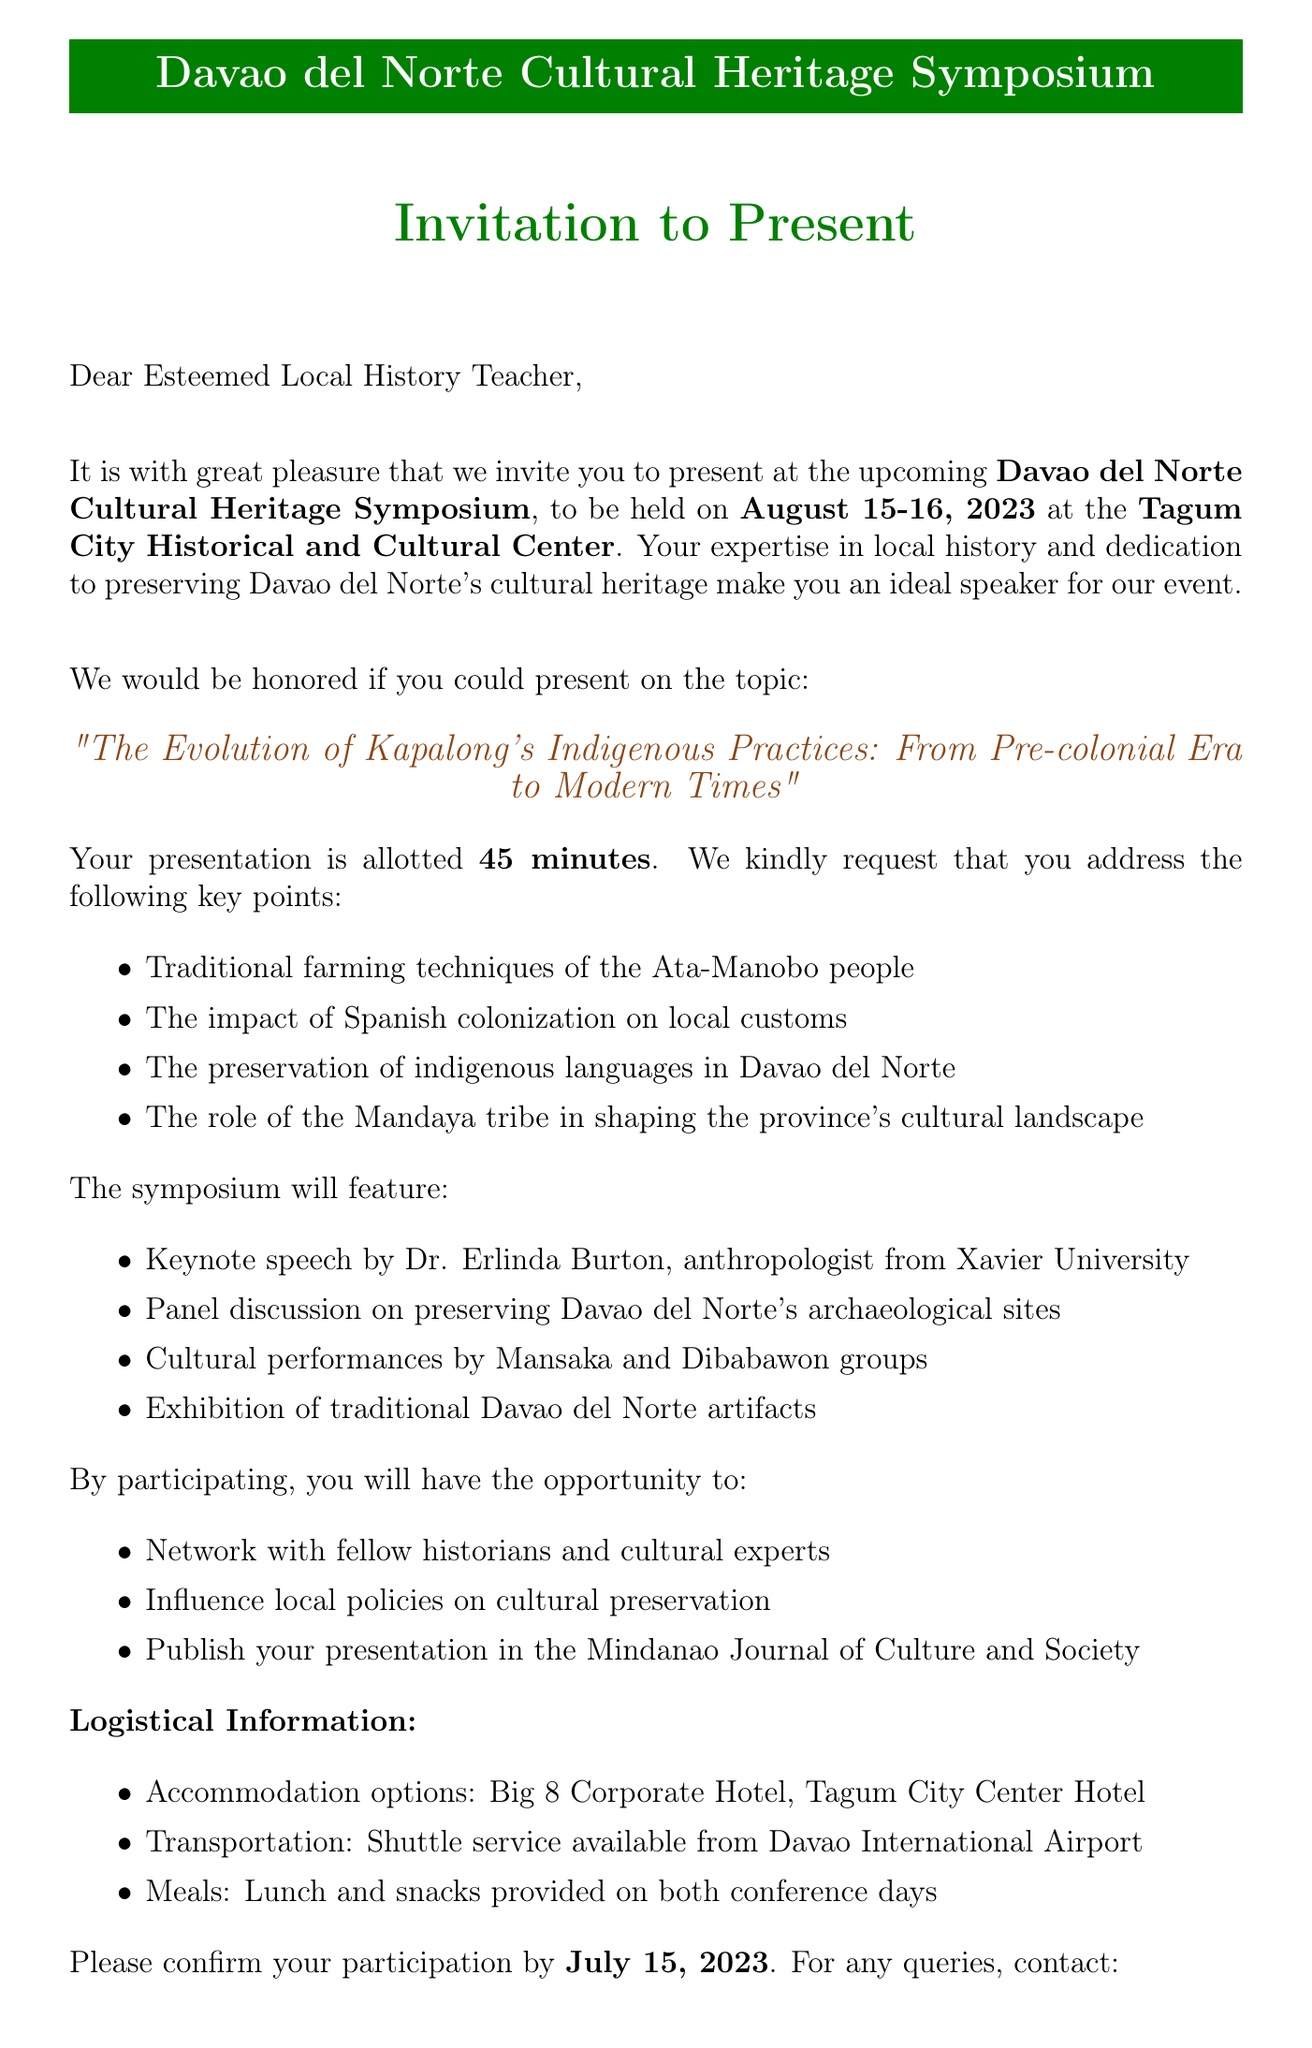What is the name of the conference? The name of the conference is specified in the document, which is the Davao del Norte Cultural Heritage Symposium.
Answer: Davao del Norte Cultural Heritage Symposium When will the symposium take place? The document states the date of the symposium as August 15-16, 2023.
Answer: August 15-16, 2023 Who is the organizer of the symposium? The document mentions that the organizer of the event is the Davao del Norte Historical Society.
Answer: Davao del Norte Historical Society What is the allotted duration for the presentation? According to the document, the presentation is allotted 45 minutes.
Answer: 45 minutes Who will deliver the keynote speech? The document specifies that Dr. Erlinda Burton, an anthropologist from Xavier University, will deliver the keynote speech.
Answer: Dr. Erlinda Burton What topic should the presentation cover? The document suggests the topic of the presentation as "The Evolution of Kapalong's Indigenous Practices: From Pre-colonial Era to Modern Times."
Answer: The Evolution of Kapalong's Indigenous Practices: From Pre-colonial Era to Modern Times What are the expected audience types? The document lists several types of attendees expected at the conference, which include local government officials, educators, cultural preservation advocates, and representatives from indigenous communities.
Answer: Local government officials, educators, cultural preservation advocates, representatives from indigenous communities What is the response deadline for the invitation? The response deadline is mentioned in the document as July 15, 2023.
Answer: July 15, 2023 What kind of meal provisions will be provided? The document states that lunch and snacks will be provided on both conference days.
Answer: Lunch and snacks 